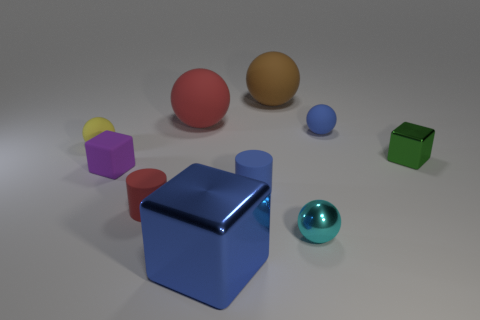How might light be interacting with the surfaces of these objects? The objects are illuminated in a way that produces soft shadows, suggesting a diffuse light source. The glossy surfaces, like that of the blue cube and the shiny purple sphere, reflect the light brightly, creating highlights, whereas the matte surfaces, such as the green cube, absorb more light and reflect less, thus appearing flatter in contrast. 